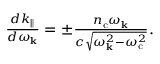Convert formula to latex. <formula><loc_0><loc_0><loc_500><loc_500>\begin{array} { r } { \frac { d k _ { \| } } { d \omega _ { k } } = \pm \frac { n _ { c } \omega _ { k } } { c \sqrt { \omega _ { k } ^ { 2 } - \omega _ { c } ^ { 2 } } } . } \end{array}</formula> 